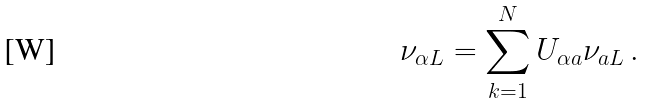Convert formula to latex. <formula><loc_0><loc_0><loc_500><loc_500>\nu _ { \alpha L } = \sum _ { k = 1 } ^ { N } U _ { \alpha a } \nu _ { a L } \, .</formula> 